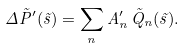<formula> <loc_0><loc_0><loc_500><loc_500>\Delta \tilde { P } ^ { \prime } ( \vec { s } ) = \sum _ { n } A ^ { \prime } _ { n } \, \tilde { Q } _ { n } ( \vec { s } ) .</formula> 